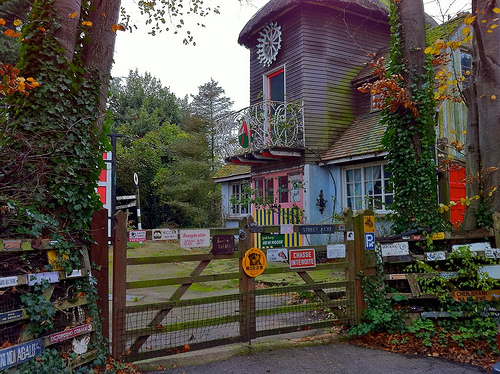<image>
Can you confirm if the fence is on the house? No. The fence is not positioned on the house. They may be near each other, but the fence is not supported by or resting on top of the house. 